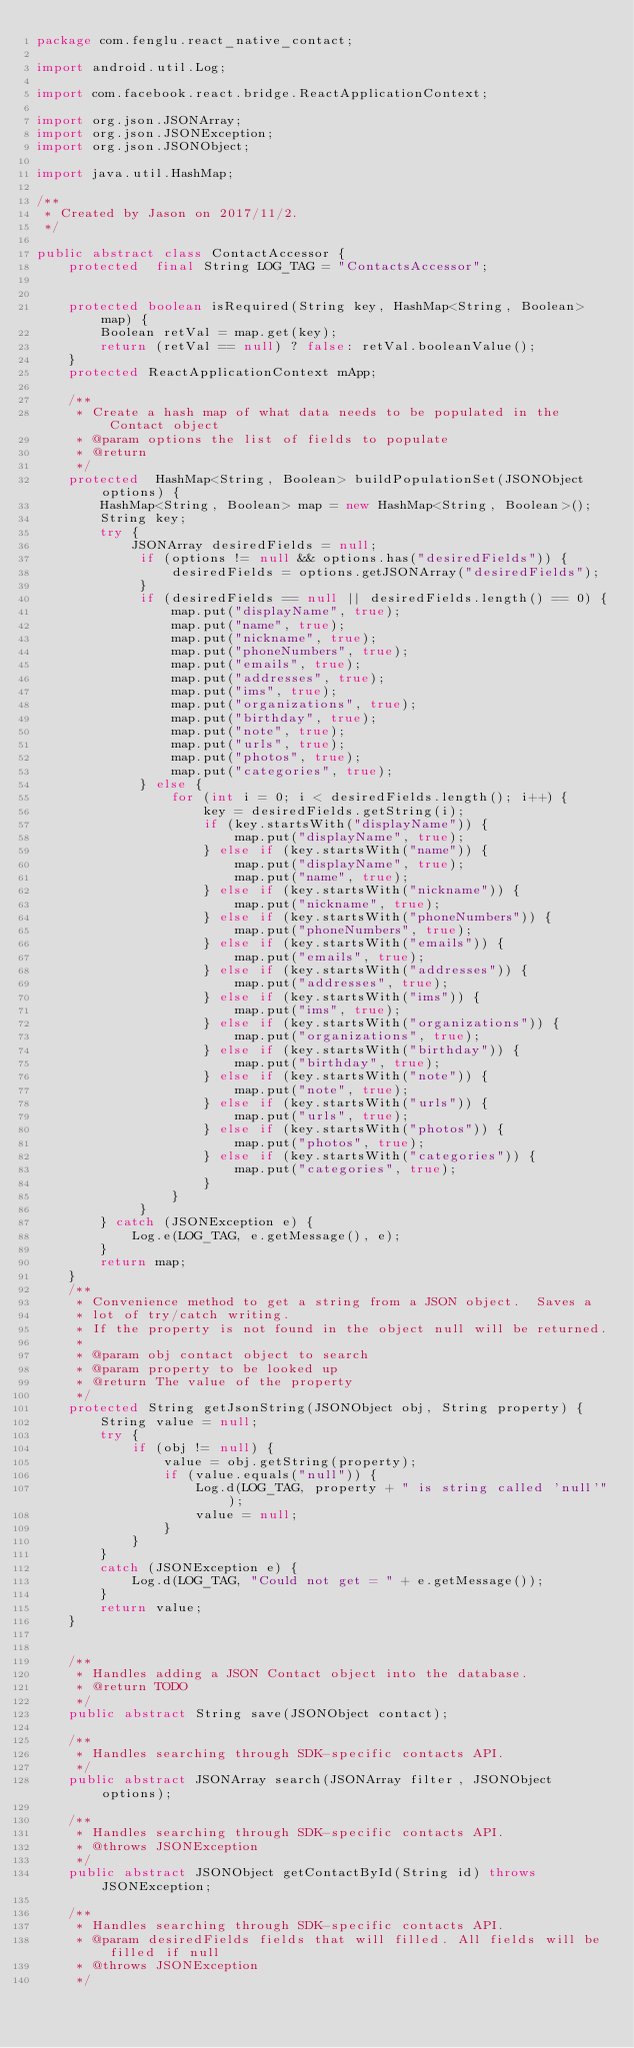Convert code to text. <code><loc_0><loc_0><loc_500><loc_500><_Java_>package com.fenglu.react_native_contact;

import android.util.Log;

import com.facebook.react.bridge.ReactApplicationContext;

import org.json.JSONArray;
import org.json.JSONException;
import org.json.JSONObject;

import java.util.HashMap;

/**
 * Created by Jason on 2017/11/2.
 */

public abstract class ContactAccessor {
    protected  final String LOG_TAG = "ContactsAccessor";


    protected boolean isRequired(String key, HashMap<String, Boolean> map) {
        Boolean retVal = map.get(key);
        return (retVal == null) ? false: retVal.booleanValue();
    }
    protected ReactApplicationContext mApp;

    /**
     * Create a hash map of what data needs to be populated in the Contact object
     * @param options the list of fields to populate
     * @return
     */
    protected  HashMap<String, Boolean> buildPopulationSet(JSONObject options) {
        HashMap<String, Boolean> map = new HashMap<String, Boolean>();
        String key;
        try {
            JSONArray desiredFields = null;
             if (options != null && options.has("desiredFields")) {
                 desiredFields = options.getJSONArray("desiredFields");
             }
             if (desiredFields == null || desiredFields.length() == 0) {
                 map.put("displayName", true);
                 map.put("name", true);
                 map.put("nickname", true);
                 map.put("phoneNumbers", true);
                 map.put("emails", true);
                 map.put("addresses", true);
                 map.put("ims", true);
                 map.put("organizations", true);
                 map.put("birthday", true);
                 map.put("note", true);
                 map.put("urls", true);
                 map.put("photos", true);
                 map.put("categories", true);
             } else {
                 for (int i = 0; i < desiredFields.length(); i++) {
                     key = desiredFields.getString(i);
                     if (key.startsWith("displayName")) {
                         map.put("displayName", true);
                     } else if (key.startsWith("name")) {
                         map.put("displayName", true);
                         map.put("name", true);
                     } else if (key.startsWith("nickname")) {
                         map.put("nickname", true);
                     } else if (key.startsWith("phoneNumbers")) {
                         map.put("phoneNumbers", true);
                     } else if (key.startsWith("emails")) {
                         map.put("emails", true);
                     } else if (key.startsWith("addresses")) {
                         map.put("addresses", true);
                     } else if (key.startsWith("ims")) {
                         map.put("ims", true);
                     } else if (key.startsWith("organizations")) {
                         map.put("organizations", true);
                     } else if (key.startsWith("birthday")) {
                         map.put("birthday", true);
                     } else if (key.startsWith("note")) {
                         map.put("note", true);
                     } else if (key.startsWith("urls")) {
                         map.put("urls", true);
                     } else if (key.startsWith("photos")) {
                         map.put("photos", true);
                     } else if (key.startsWith("categories")) {
                         map.put("categories", true);
                     }
                 }
             }
        } catch (JSONException e) {
            Log.e(LOG_TAG, e.getMessage(), e);
        }
        return map;
    }
    /**
     * Convenience method to get a string from a JSON object.  Saves a
     * lot of try/catch writing.
     * If the property is not found in the object null will be returned.
     *
     * @param obj contact object to search
     * @param property to be looked up
     * @return The value of the property
     */
    protected String getJsonString(JSONObject obj, String property) {
        String value = null;
        try {
            if (obj != null) {
                value = obj.getString(property);
                if (value.equals("null")) {
                    Log.d(LOG_TAG, property + " is string called 'null'");
                    value = null;
                }
            }
        }
        catch (JSONException e) {
            Log.d(LOG_TAG, "Could not get = " + e.getMessage());
        }
        return value;
    }


    /**
     * Handles adding a JSON Contact object into the database.
     * @return TODO
     */
    public abstract String save(JSONObject contact);

    /**
     * Handles searching through SDK-specific contacts API.
     */
    public abstract JSONArray search(JSONArray filter, JSONObject options);

    /**
     * Handles searching through SDK-specific contacts API.
     * @throws JSONException
     */
    public abstract JSONObject getContactById(String id) throws JSONException;

    /**
     * Handles searching through SDK-specific contacts API.
     * @param desiredFields fields that will filled. All fields will be filled if null
     * @throws JSONException
     */</code> 